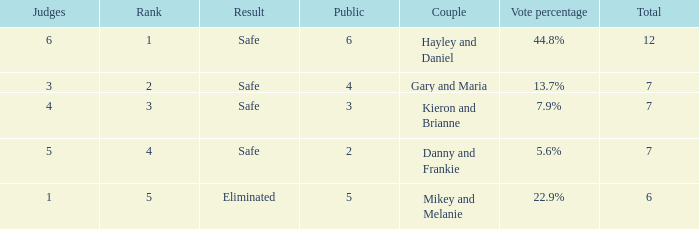What was the result for the total of 12? Safe. 